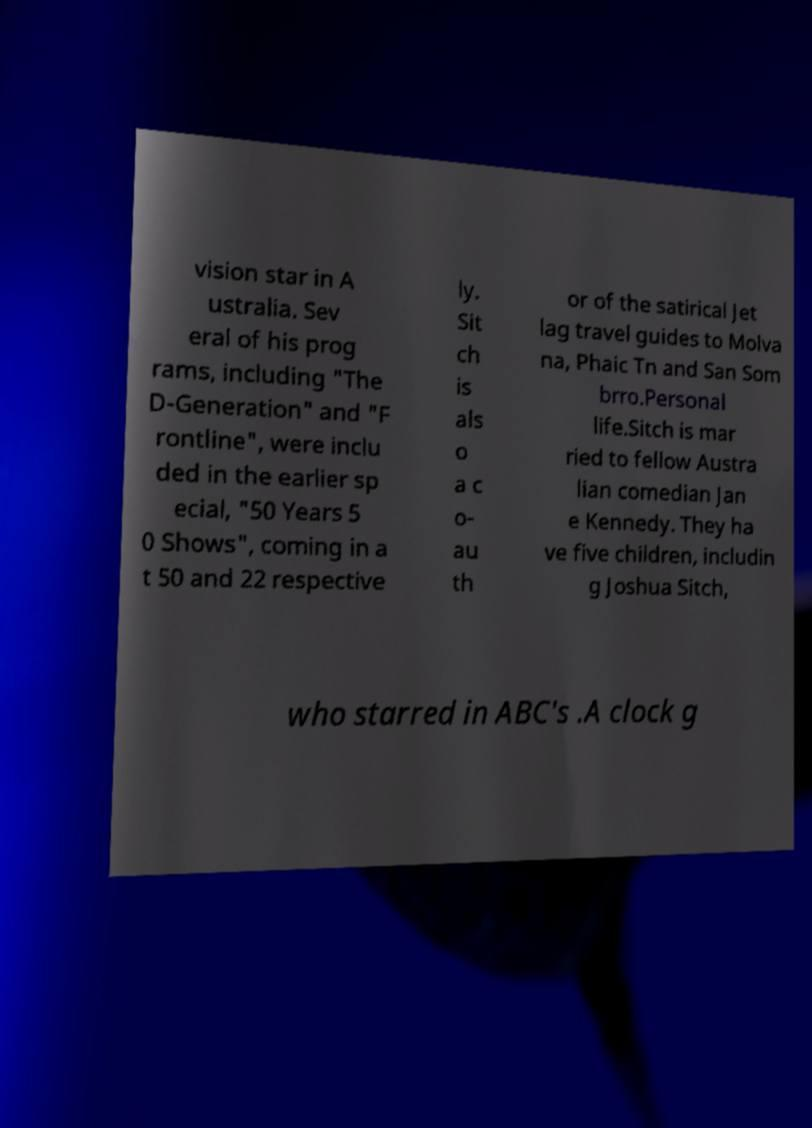Can you accurately transcribe the text from the provided image for me? vision star in A ustralia. Sev eral of his prog rams, including "The D-Generation" and "F rontline", were inclu ded in the earlier sp ecial, "50 Years 5 0 Shows", coming in a t 50 and 22 respective ly. Sit ch is als o a c o- au th or of the satirical Jet lag travel guides to Molva na, Phaic Tn and San Som brro.Personal life.Sitch is mar ried to fellow Austra lian comedian Jan e Kennedy. They ha ve five children, includin g Joshua Sitch, who starred in ABC's .A clock g 